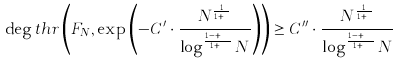<formula> <loc_0><loc_0><loc_500><loc_500>\deg t h r \left ( F _ { N } , \exp \left ( - C ^ { \prime } \cdot \frac { N ^ { \frac { 1 } { 1 + \alpha } } } { \log ^ { \frac { 1 - \alpha + \beta } { 1 + \alpha } } N } \right ) \right ) \geq C ^ { \prime \prime } \cdot \frac { N ^ { \frac { 1 } { 1 + \alpha } } } { \log ^ { \frac { 1 - \alpha + \beta } { 1 + \alpha } } N }</formula> 